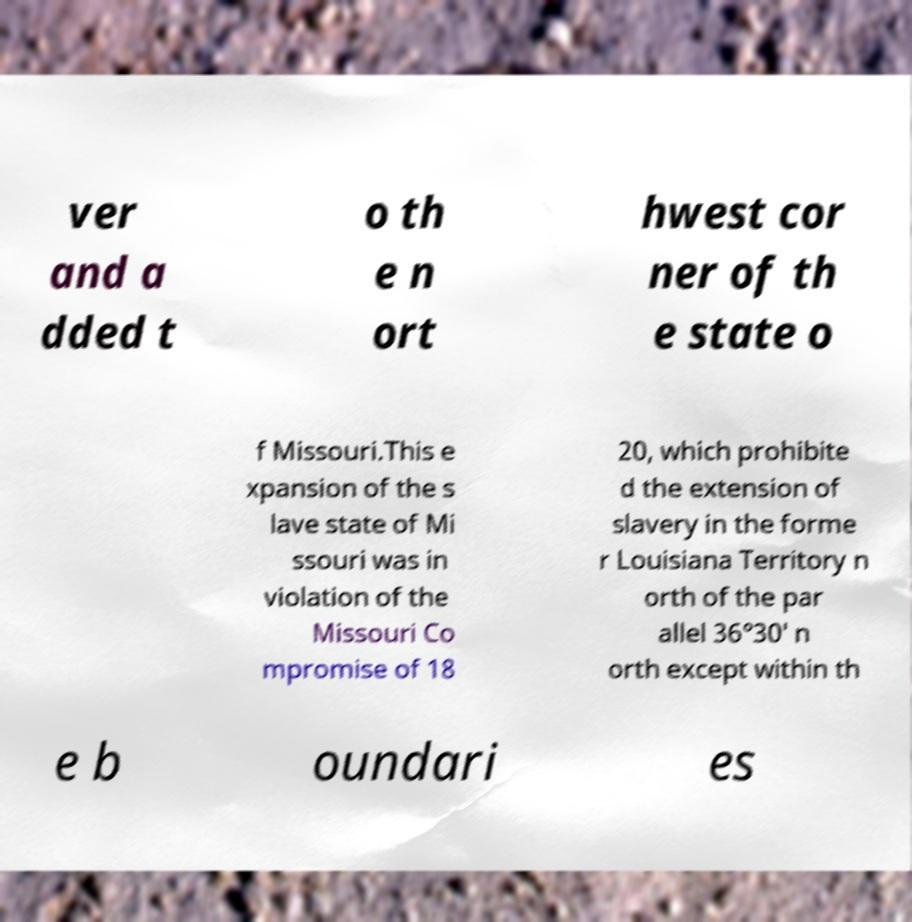I need the written content from this picture converted into text. Can you do that? ver and a dded t o th e n ort hwest cor ner of th e state o f Missouri.This e xpansion of the s lave state of Mi ssouri was in violation of the Missouri Co mpromise of 18 20, which prohibite d the extension of slavery in the forme r Louisiana Territory n orth of the par allel 36°30′ n orth except within th e b oundari es 